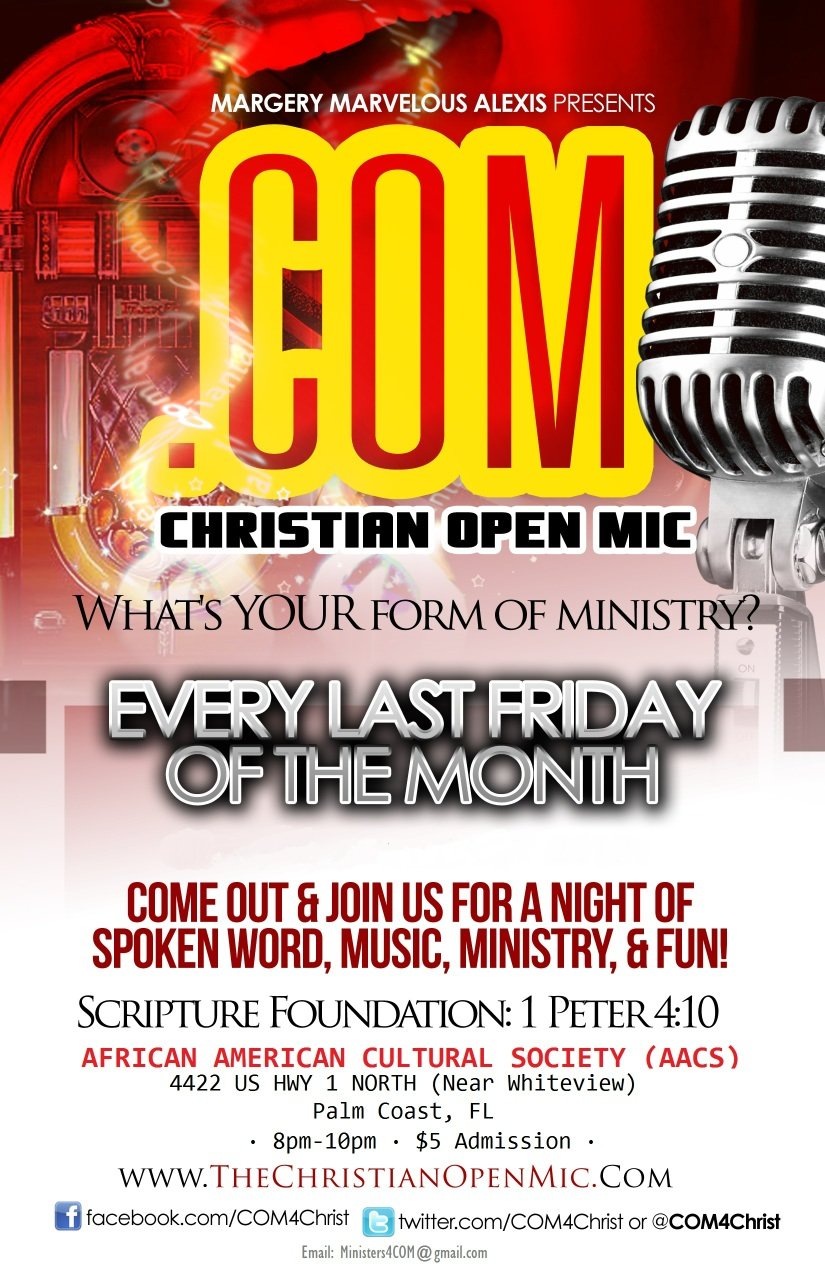What kind of activities can one expect at the Christian Open Mic event? Attendees of the Christian Open Mic event can look forward to a diverse range of activities. These include spoken word performances, live music, ministry sessions, and various forms of artistic expression. It's a vibrant and inclusive gathering designed to celebrate faith and community through creativity and shared talents. 